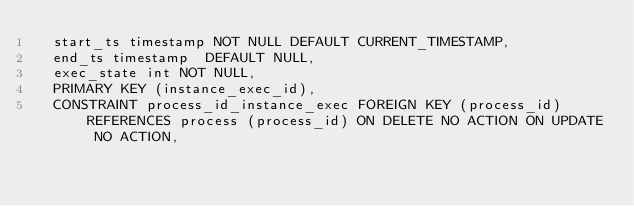<code> <loc_0><loc_0><loc_500><loc_500><_SQL_>  start_ts timestamp NOT NULL DEFAULT CURRENT_TIMESTAMP,
  end_ts timestamp  DEFAULT NULL,
  exec_state int NOT NULL,
  PRIMARY KEY (instance_exec_id),
  CONSTRAINT process_id_instance_exec FOREIGN KEY (process_id) REFERENCES process (process_id) ON DELETE NO ACTION ON UPDATE NO ACTION,</code> 